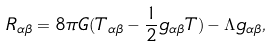<formula> <loc_0><loc_0><loc_500><loc_500>R _ { \alpha \beta } = 8 \pi G ( T _ { \alpha \beta } - \frac { 1 } { 2 } g _ { \alpha \beta } T ) - \Lambda g _ { \alpha \beta } ,</formula> 